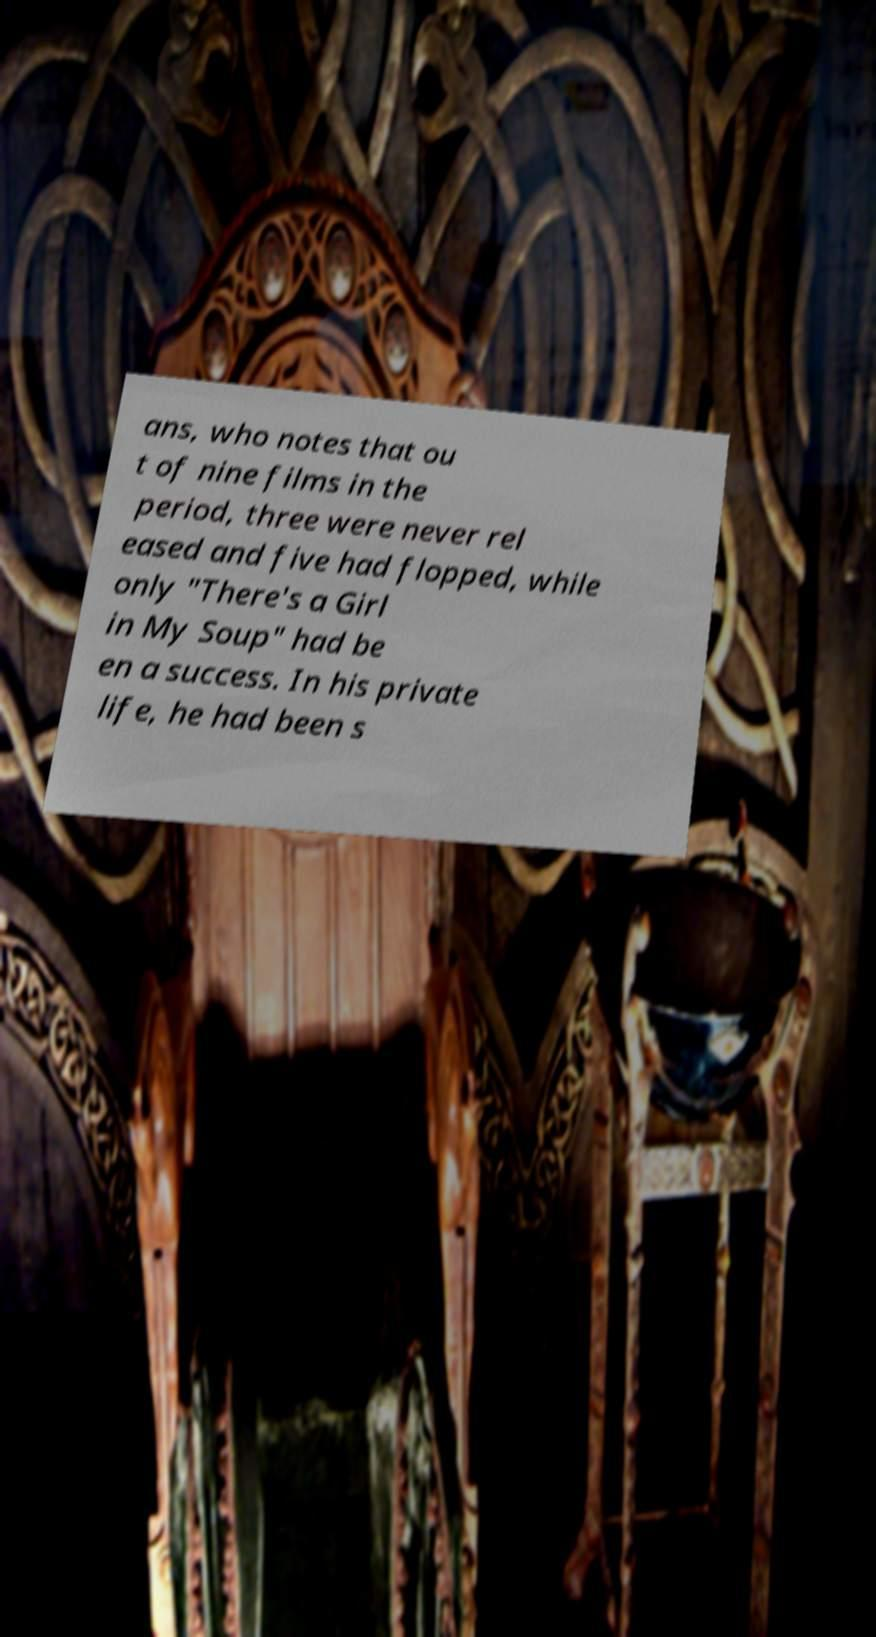Could you extract and type out the text from this image? ans, who notes that ou t of nine films in the period, three were never rel eased and five had flopped, while only "There's a Girl in My Soup" had be en a success. In his private life, he had been s 